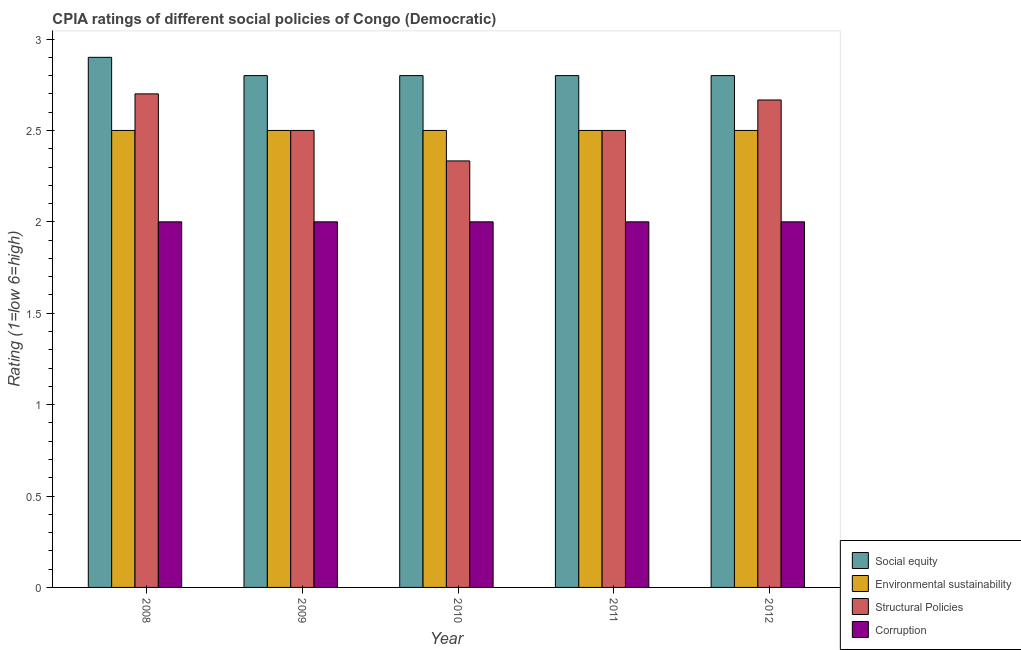How many different coloured bars are there?
Offer a terse response. 4. How many groups of bars are there?
Your answer should be compact. 5. What is the label of the 1st group of bars from the left?
Provide a succinct answer. 2008. What is the cpia rating of social equity in 2012?
Your response must be concise. 2.8. Across all years, what is the maximum cpia rating of corruption?
Offer a very short reply. 2. Across all years, what is the minimum cpia rating of corruption?
Your response must be concise. 2. What is the difference between the cpia rating of social equity in 2008 and that in 2011?
Your response must be concise. 0.1. What is the average cpia rating of structural policies per year?
Offer a terse response. 2.54. In the year 2008, what is the difference between the cpia rating of environmental sustainability and cpia rating of structural policies?
Your answer should be very brief. 0. In how many years, is the cpia rating of environmental sustainability greater than 2.6?
Offer a terse response. 0. What is the ratio of the cpia rating of environmental sustainability in 2009 to that in 2011?
Give a very brief answer. 1. What is the difference between the highest and the second highest cpia rating of structural policies?
Offer a very short reply. 0.03. What is the difference between the highest and the lowest cpia rating of environmental sustainability?
Your answer should be compact. 0. Is the sum of the cpia rating of corruption in 2011 and 2012 greater than the maximum cpia rating of environmental sustainability across all years?
Your response must be concise. Yes. What does the 1st bar from the left in 2010 represents?
Offer a terse response. Social equity. What does the 4th bar from the right in 2009 represents?
Ensure brevity in your answer.  Social equity. What is the difference between two consecutive major ticks on the Y-axis?
Provide a short and direct response. 0.5. Are the values on the major ticks of Y-axis written in scientific E-notation?
Your response must be concise. No. Does the graph contain grids?
Your response must be concise. No. Where does the legend appear in the graph?
Offer a very short reply. Bottom right. How are the legend labels stacked?
Provide a succinct answer. Vertical. What is the title of the graph?
Your answer should be very brief. CPIA ratings of different social policies of Congo (Democratic). Does "Taxes on exports" appear as one of the legend labels in the graph?
Offer a terse response. No. What is the label or title of the X-axis?
Your response must be concise. Year. What is the Rating (1=low 6=high) in Social equity in 2008?
Ensure brevity in your answer.  2.9. What is the Rating (1=low 6=high) of Environmental sustainability in 2008?
Your answer should be compact. 2.5. What is the Rating (1=low 6=high) in Social equity in 2009?
Ensure brevity in your answer.  2.8. What is the Rating (1=low 6=high) in Environmental sustainability in 2009?
Your answer should be very brief. 2.5. What is the Rating (1=low 6=high) in Environmental sustainability in 2010?
Make the answer very short. 2.5. What is the Rating (1=low 6=high) of Structural Policies in 2010?
Offer a very short reply. 2.33. What is the Rating (1=low 6=high) of Social equity in 2012?
Your answer should be very brief. 2.8. What is the Rating (1=low 6=high) of Structural Policies in 2012?
Offer a very short reply. 2.67. What is the Rating (1=low 6=high) in Corruption in 2012?
Offer a very short reply. 2. Across all years, what is the maximum Rating (1=low 6=high) in Environmental sustainability?
Your answer should be compact. 2.5. Across all years, what is the maximum Rating (1=low 6=high) in Structural Policies?
Your answer should be compact. 2.7. Across all years, what is the minimum Rating (1=low 6=high) of Environmental sustainability?
Your response must be concise. 2.5. Across all years, what is the minimum Rating (1=low 6=high) of Structural Policies?
Provide a short and direct response. 2.33. Across all years, what is the minimum Rating (1=low 6=high) of Corruption?
Make the answer very short. 2. What is the total Rating (1=low 6=high) in Social equity in the graph?
Keep it short and to the point. 14.1. What is the total Rating (1=low 6=high) of Structural Policies in the graph?
Give a very brief answer. 12.7. What is the difference between the Rating (1=low 6=high) of Environmental sustainability in 2008 and that in 2009?
Ensure brevity in your answer.  0. What is the difference between the Rating (1=low 6=high) of Structural Policies in 2008 and that in 2010?
Provide a short and direct response. 0.37. What is the difference between the Rating (1=low 6=high) of Social equity in 2008 and that in 2011?
Make the answer very short. 0.1. What is the difference between the Rating (1=low 6=high) in Environmental sustainability in 2008 and that in 2011?
Your answer should be very brief. 0. What is the difference between the Rating (1=low 6=high) of Social equity in 2008 and that in 2012?
Provide a succinct answer. 0.1. What is the difference between the Rating (1=low 6=high) of Environmental sustainability in 2008 and that in 2012?
Give a very brief answer. 0. What is the difference between the Rating (1=low 6=high) in Structural Policies in 2008 and that in 2012?
Your answer should be compact. 0.03. What is the difference between the Rating (1=low 6=high) in Corruption in 2008 and that in 2012?
Offer a terse response. 0. What is the difference between the Rating (1=low 6=high) of Social equity in 2009 and that in 2010?
Offer a very short reply. 0. What is the difference between the Rating (1=low 6=high) in Environmental sustainability in 2009 and that in 2010?
Ensure brevity in your answer.  0. What is the difference between the Rating (1=low 6=high) of Structural Policies in 2009 and that in 2010?
Keep it short and to the point. 0.17. What is the difference between the Rating (1=low 6=high) of Corruption in 2009 and that in 2010?
Make the answer very short. 0. What is the difference between the Rating (1=low 6=high) in Environmental sustainability in 2009 and that in 2011?
Offer a terse response. 0. What is the difference between the Rating (1=low 6=high) in Structural Policies in 2009 and that in 2011?
Provide a succinct answer. 0. What is the difference between the Rating (1=low 6=high) in Environmental sustainability in 2009 and that in 2012?
Ensure brevity in your answer.  0. What is the difference between the Rating (1=low 6=high) in Structural Policies in 2009 and that in 2012?
Your answer should be compact. -0.17. What is the difference between the Rating (1=low 6=high) in Corruption in 2009 and that in 2012?
Ensure brevity in your answer.  0. What is the difference between the Rating (1=low 6=high) in Structural Policies in 2010 and that in 2011?
Your answer should be compact. -0.17. What is the difference between the Rating (1=low 6=high) in Social equity in 2010 and that in 2012?
Offer a terse response. 0. What is the difference between the Rating (1=low 6=high) in Environmental sustainability in 2010 and that in 2012?
Your response must be concise. 0. What is the difference between the Rating (1=low 6=high) of Structural Policies in 2010 and that in 2012?
Offer a terse response. -0.33. What is the difference between the Rating (1=low 6=high) in Corruption in 2010 and that in 2012?
Offer a very short reply. 0. What is the difference between the Rating (1=low 6=high) of Environmental sustainability in 2011 and that in 2012?
Make the answer very short. 0. What is the difference between the Rating (1=low 6=high) of Corruption in 2011 and that in 2012?
Make the answer very short. 0. What is the difference between the Rating (1=low 6=high) of Social equity in 2008 and the Rating (1=low 6=high) of Environmental sustainability in 2009?
Your answer should be compact. 0.4. What is the difference between the Rating (1=low 6=high) of Environmental sustainability in 2008 and the Rating (1=low 6=high) of Structural Policies in 2009?
Offer a terse response. 0. What is the difference between the Rating (1=low 6=high) of Environmental sustainability in 2008 and the Rating (1=low 6=high) of Corruption in 2009?
Provide a short and direct response. 0.5. What is the difference between the Rating (1=low 6=high) in Structural Policies in 2008 and the Rating (1=low 6=high) in Corruption in 2009?
Your answer should be compact. 0.7. What is the difference between the Rating (1=low 6=high) of Social equity in 2008 and the Rating (1=low 6=high) of Environmental sustainability in 2010?
Ensure brevity in your answer.  0.4. What is the difference between the Rating (1=low 6=high) of Social equity in 2008 and the Rating (1=low 6=high) of Structural Policies in 2010?
Your answer should be compact. 0.57. What is the difference between the Rating (1=low 6=high) in Environmental sustainability in 2008 and the Rating (1=low 6=high) in Structural Policies in 2010?
Give a very brief answer. 0.17. What is the difference between the Rating (1=low 6=high) of Environmental sustainability in 2008 and the Rating (1=low 6=high) of Corruption in 2010?
Your response must be concise. 0.5. What is the difference between the Rating (1=low 6=high) of Social equity in 2008 and the Rating (1=low 6=high) of Environmental sustainability in 2011?
Your response must be concise. 0.4. What is the difference between the Rating (1=low 6=high) in Environmental sustainability in 2008 and the Rating (1=low 6=high) in Structural Policies in 2011?
Provide a short and direct response. 0. What is the difference between the Rating (1=low 6=high) in Structural Policies in 2008 and the Rating (1=low 6=high) in Corruption in 2011?
Your answer should be compact. 0.7. What is the difference between the Rating (1=low 6=high) of Social equity in 2008 and the Rating (1=low 6=high) of Structural Policies in 2012?
Your answer should be compact. 0.23. What is the difference between the Rating (1=low 6=high) of Social equity in 2008 and the Rating (1=low 6=high) of Corruption in 2012?
Offer a very short reply. 0.9. What is the difference between the Rating (1=low 6=high) of Environmental sustainability in 2008 and the Rating (1=low 6=high) of Structural Policies in 2012?
Keep it short and to the point. -0.17. What is the difference between the Rating (1=low 6=high) of Structural Policies in 2008 and the Rating (1=low 6=high) of Corruption in 2012?
Your response must be concise. 0.7. What is the difference between the Rating (1=low 6=high) in Social equity in 2009 and the Rating (1=low 6=high) in Environmental sustainability in 2010?
Your response must be concise. 0.3. What is the difference between the Rating (1=low 6=high) of Social equity in 2009 and the Rating (1=low 6=high) of Structural Policies in 2010?
Your answer should be compact. 0.47. What is the difference between the Rating (1=low 6=high) in Social equity in 2009 and the Rating (1=low 6=high) in Corruption in 2010?
Make the answer very short. 0.8. What is the difference between the Rating (1=low 6=high) of Environmental sustainability in 2009 and the Rating (1=low 6=high) of Structural Policies in 2010?
Ensure brevity in your answer.  0.17. What is the difference between the Rating (1=low 6=high) in Social equity in 2009 and the Rating (1=low 6=high) in Environmental sustainability in 2011?
Your answer should be compact. 0.3. What is the difference between the Rating (1=low 6=high) of Social equity in 2009 and the Rating (1=low 6=high) of Corruption in 2011?
Give a very brief answer. 0.8. What is the difference between the Rating (1=low 6=high) of Environmental sustainability in 2009 and the Rating (1=low 6=high) of Corruption in 2011?
Your answer should be compact. 0.5. What is the difference between the Rating (1=low 6=high) of Structural Policies in 2009 and the Rating (1=low 6=high) of Corruption in 2011?
Make the answer very short. 0.5. What is the difference between the Rating (1=low 6=high) of Social equity in 2009 and the Rating (1=low 6=high) of Environmental sustainability in 2012?
Offer a very short reply. 0.3. What is the difference between the Rating (1=low 6=high) in Social equity in 2009 and the Rating (1=low 6=high) in Structural Policies in 2012?
Your answer should be very brief. 0.13. What is the difference between the Rating (1=low 6=high) of Social equity in 2009 and the Rating (1=low 6=high) of Corruption in 2012?
Provide a short and direct response. 0.8. What is the difference between the Rating (1=low 6=high) in Environmental sustainability in 2009 and the Rating (1=low 6=high) in Corruption in 2012?
Make the answer very short. 0.5. What is the difference between the Rating (1=low 6=high) of Structural Policies in 2009 and the Rating (1=low 6=high) of Corruption in 2012?
Provide a succinct answer. 0.5. What is the difference between the Rating (1=low 6=high) in Social equity in 2010 and the Rating (1=low 6=high) in Structural Policies in 2011?
Ensure brevity in your answer.  0.3. What is the difference between the Rating (1=low 6=high) of Environmental sustainability in 2010 and the Rating (1=low 6=high) of Corruption in 2011?
Provide a succinct answer. 0.5. What is the difference between the Rating (1=low 6=high) of Structural Policies in 2010 and the Rating (1=low 6=high) of Corruption in 2011?
Make the answer very short. 0.33. What is the difference between the Rating (1=low 6=high) of Social equity in 2010 and the Rating (1=low 6=high) of Structural Policies in 2012?
Your answer should be very brief. 0.13. What is the difference between the Rating (1=low 6=high) of Social equity in 2010 and the Rating (1=low 6=high) of Corruption in 2012?
Your response must be concise. 0.8. What is the difference between the Rating (1=low 6=high) of Environmental sustainability in 2010 and the Rating (1=low 6=high) of Corruption in 2012?
Your answer should be compact. 0.5. What is the difference between the Rating (1=low 6=high) of Structural Policies in 2010 and the Rating (1=low 6=high) of Corruption in 2012?
Keep it short and to the point. 0.33. What is the difference between the Rating (1=low 6=high) in Social equity in 2011 and the Rating (1=low 6=high) in Structural Policies in 2012?
Give a very brief answer. 0.13. What is the average Rating (1=low 6=high) in Social equity per year?
Make the answer very short. 2.82. What is the average Rating (1=low 6=high) of Structural Policies per year?
Keep it short and to the point. 2.54. What is the average Rating (1=low 6=high) of Corruption per year?
Your response must be concise. 2. In the year 2008, what is the difference between the Rating (1=low 6=high) in Environmental sustainability and Rating (1=low 6=high) in Corruption?
Give a very brief answer. 0.5. In the year 2008, what is the difference between the Rating (1=low 6=high) in Structural Policies and Rating (1=low 6=high) in Corruption?
Keep it short and to the point. 0.7. In the year 2009, what is the difference between the Rating (1=low 6=high) of Social equity and Rating (1=low 6=high) of Structural Policies?
Your answer should be compact. 0.3. In the year 2009, what is the difference between the Rating (1=low 6=high) in Environmental sustainability and Rating (1=low 6=high) in Structural Policies?
Your answer should be very brief. 0. In the year 2009, what is the difference between the Rating (1=low 6=high) in Environmental sustainability and Rating (1=low 6=high) in Corruption?
Give a very brief answer. 0.5. In the year 2010, what is the difference between the Rating (1=low 6=high) of Social equity and Rating (1=low 6=high) of Structural Policies?
Make the answer very short. 0.47. In the year 2010, what is the difference between the Rating (1=low 6=high) of Structural Policies and Rating (1=low 6=high) of Corruption?
Ensure brevity in your answer.  0.33. In the year 2011, what is the difference between the Rating (1=low 6=high) in Social equity and Rating (1=low 6=high) in Environmental sustainability?
Offer a very short reply. 0.3. In the year 2011, what is the difference between the Rating (1=low 6=high) in Social equity and Rating (1=low 6=high) in Structural Policies?
Give a very brief answer. 0.3. In the year 2011, what is the difference between the Rating (1=low 6=high) of Social equity and Rating (1=low 6=high) of Corruption?
Your answer should be compact. 0.8. In the year 2011, what is the difference between the Rating (1=low 6=high) of Environmental sustainability and Rating (1=low 6=high) of Corruption?
Give a very brief answer. 0.5. In the year 2012, what is the difference between the Rating (1=low 6=high) in Social equity and Rating (1=low 6=high) in Structural Policies?
Provide a short and direct response. 0.13. In the year 2012, what is the difference between the Rating (1=low 6=high) of Social equity and Rating (1=low 6=high) of Corruption?
Your answer should be very brief. 0.8. In the year 2012, what is the difference between the Rating (1=low 6=high) of Environmental sustainability and Rating (1=low 6=high) of Corruption?
Provide a short and direct response. 0.5. What is the ratio of the Rating (1=low 6=high) of Social equity in 2008 to that in 2009?
Provide a succinct answer. 1.04. What is the ratio of the Rating (1=low 6=high) of Social equity in 2008 to that in 2010?
Offer a terse response. 1.04. What is the ratio of the Rating (1=low 6=high) of Environmental sustainability in 2008 to that in 2010?
Keep it short and to the point. 1. What is the ratio of the Rating (1=low 6=high) in Structural Policies in 2008 to that in 2010?
Provide a short and direct response. 1.16. What is the ratio of the Rating (1=low 6=high) in Social equity in 2008 to that in 2011?
Your response must be concise. 1.04. What is the ratio of the Rating (1=low 6=high) of Environmental sustainability in 2008 to that in 2011?
Your answer should be compact. 1. What is the ratio of the Rating (1=low 6=high) of Structural Policies in 2008 to that in 2011?
Offer a terse response. 1.08. What is the ratio of the Rating (1=low 6=high) in Social equity in 2008 to that in 2012?
Provide a short and direct response. 1.04. What is the ratio of the Rating (1=low 6=high) in Structural Policies in 2008 to that in 2012?
Your answer should be compact. 1.01. What is the ratio of the Rating (1=low 6=high) in Corruption in 2008 to that in 2012?
Make the answer very short. 1. What is the ratio of the Rating (1=low 6=high) of Environmental sustainability in 2009 to that in 2010?
Make the answer very short. 1. What is the ratio of the Rating (1=low 6=high) in Structural Policies in 2009 to that in 2010?
Offer a very short reply. 1.07. What is the ratio of the Rating (1=low 6=high) of Corruption in 2009 to that in 2010?
Offer a terse response. 1. What is the ratio of the Rating (1=low 6=high) in Social equity in 2009 to that in 2011?
Make the answer very short. 1. What is the ratio of the Rating (1=low 6=high) in Environmental sustainability in 2009 to that in 2011?
Make the answer very short. 1. What is the ratio of the Rating (1=low 6=high) of Corruption in 2009 to that in 2011?
Ensure brevity in your answer.  1. What is the ratio of the Rating (1=low 6=high) of Environmental sustainability in 2009 to that in 2012?
Give a very brief answer. 1. What is the ratio of the Rating (1=low 6=high) of Environmental sustainability in 2010 to that in 2011?
Offer a terse response. 1. What is the ratio of the Rating (1=low 6=high) of Corruption in 2010 to that in 2011?
Your answer should be compact. 1. What is the ratio of the Rating (1=low 6=high) of Social equity in 2010 to that in 2012?
Offer a terse response. 1. What is the ratio of the Rating (1=low 6=high) in Environmental sustainability in 2010 to that in 2012?
Make the answer very short. 1. What is the ratio of the Rating (1=low 6=high) of Social equity in 2011 to that in 2012?
Provide a succinct answer. 1. What is the ratio of the Rating (1=low 6=high) in Corruption in 2011 to that in 2012?
Your response must be concise. 1. What is the difference between the highest and the second highest Rating (1=low 6=high) in Structural Policies?
Offer a very short reply. 0.03. What is the difference between the highest and the second highest Rating (1=low 6=high) in Corruption?
Offer a terse response. 0. What is the difference between the highest and the lowest Rating (1=low 6=high) of Social equity?
Provide a short and direct response. 0.1. What is the difference between the highest and the lowest Rating (1=low 6=high) of Structural Policies?
Make the answer very short. 0.37. 